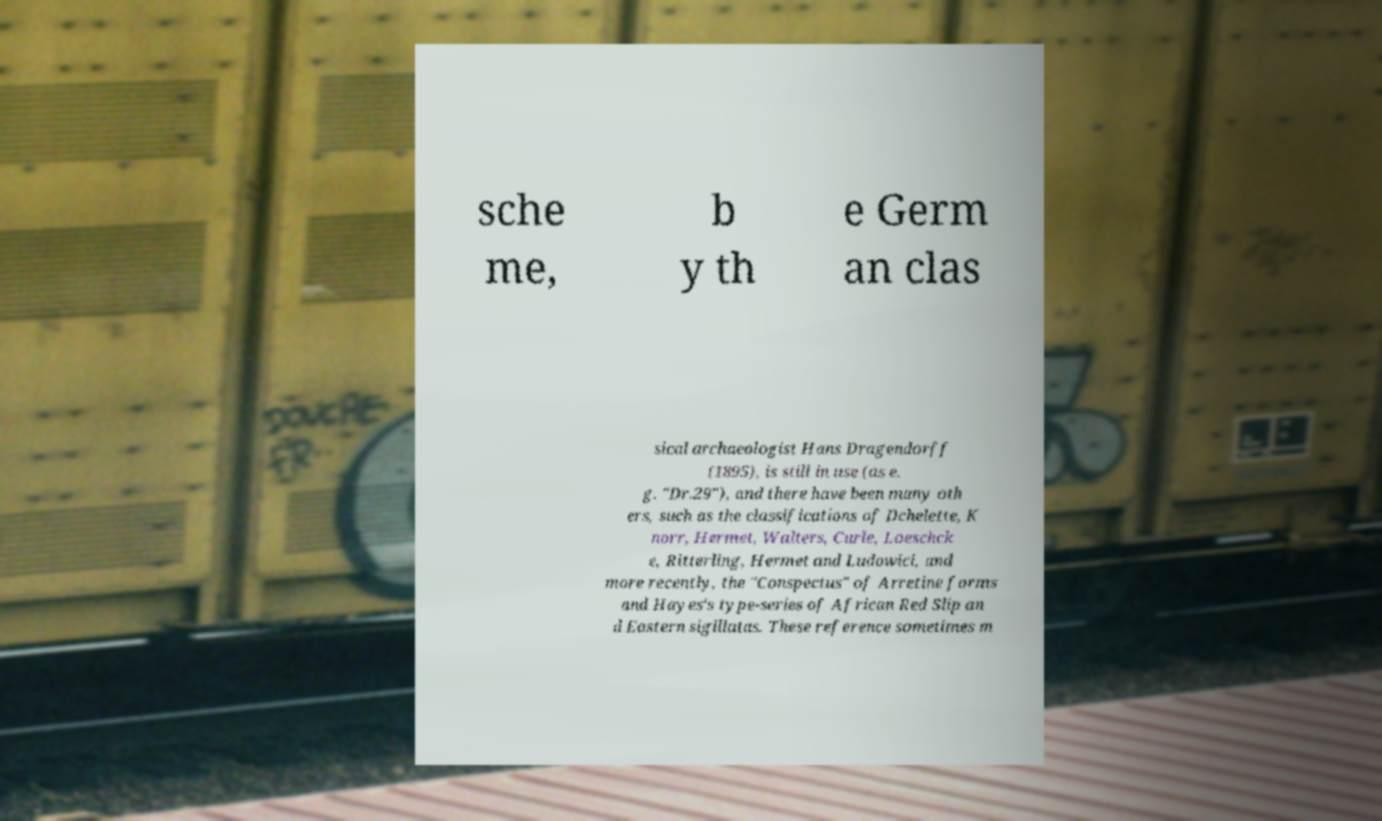What messages or text are displayed in this image? I need them in a readable, typed format. sche me, b y th e Germ an clas sical archaeologist Hans Dragendorff (1895), is still in use (as e. g. "Dr.29"), and there have been many oth ers, such as the classifications of Dchelette, K norr, Hermet, Walters, Curle, Loeschck e, Ritterling, Hermet and Ludowici, and more recently, the "Conspectus" of Arretine forms and Hayes's type-series of African Red Slip an d Eastern sigillatas. These reference sometimes m 